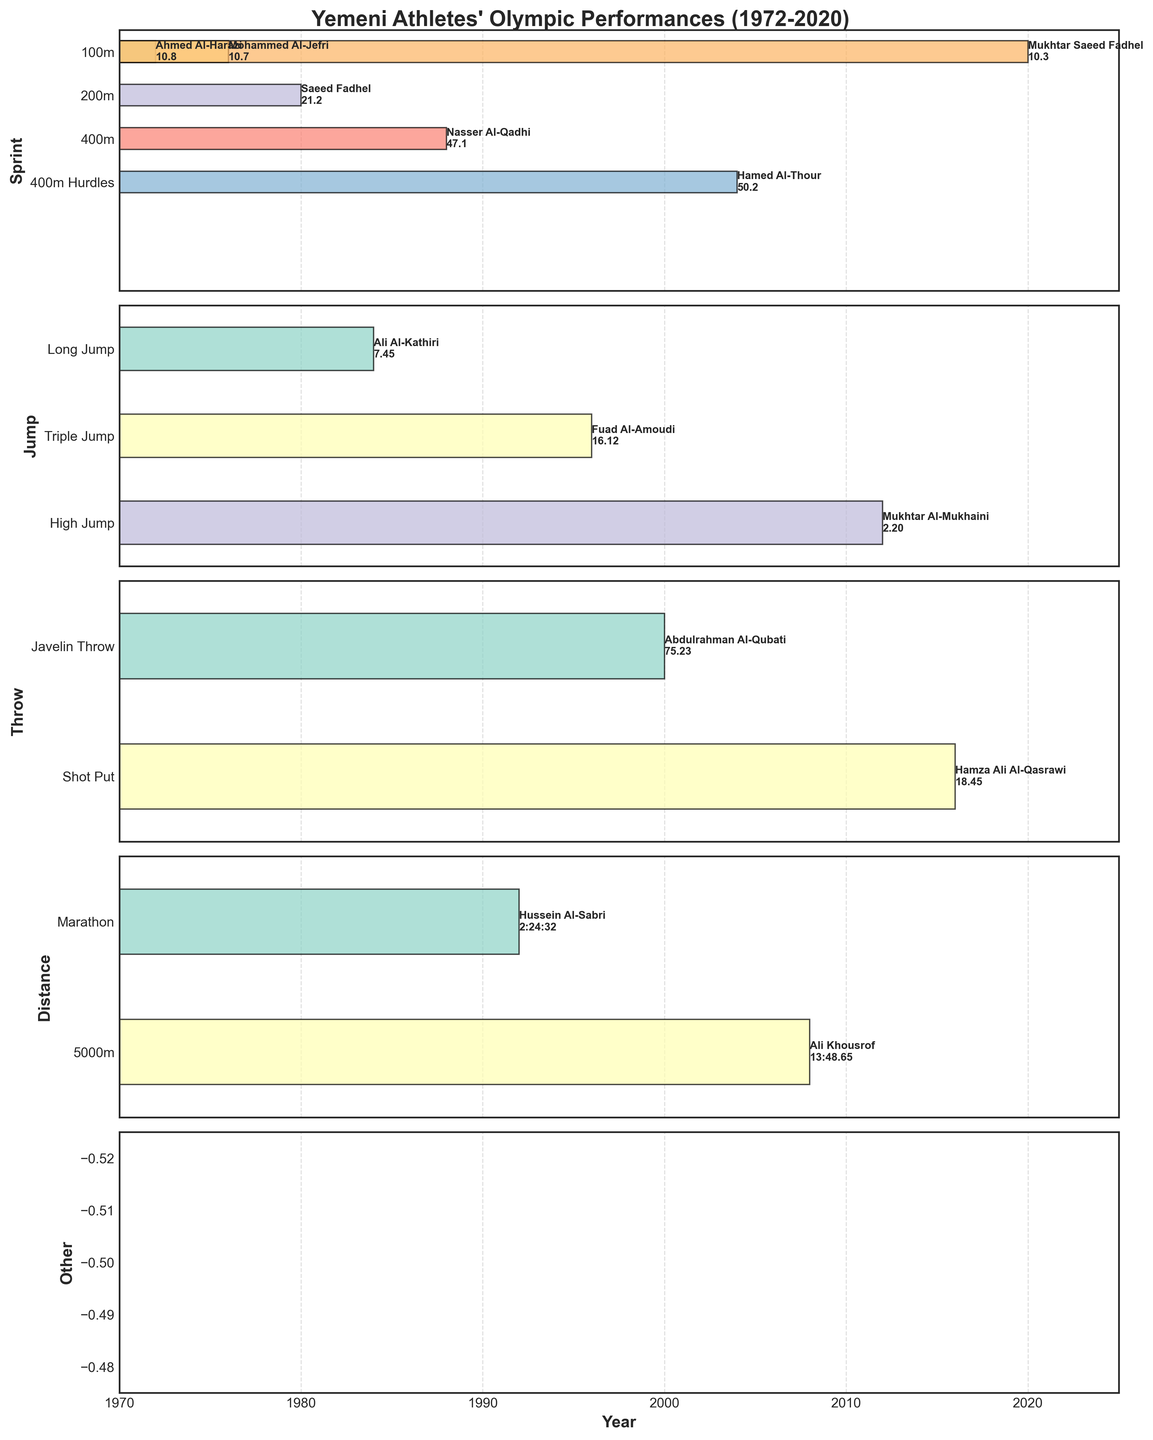In which year did Mukhtar Saeed Fadhel participate in the 100m event, and what was his performance? Mukhtar Saeed Fadhel's performance and year are highlighted in the Sprint category section of the plot, where you can see the year 2020 and the corresponding performance of 10.3.
Answer: 2020, 10.3 How many athletes represented Yemen in the "Jump" category, and what events did they participate in? There are three events under the Jump category: Long Jump, Triple Jump, and High Jump. By examining those events in the plot, we can see three athletes: Ali Al-Kathiri (Long Jump), Fuad Al-Amoudi (Triple Jump), and Mukhtar Al-Mukhaini (High Jump).
Answer: 3 athletes, Long Jump, Triple Jump, High Jump Which event had the highest number of different athletes participating across the years? View each subplot to count the number of athletes per event. The 100m event in the Sprint category has the most athletes, with Ahmed Al-Harazi, Mohammed Al-Jefri, and Mukhtar Saeed Fadhel totaling 3.
Answer: 100m, 3 athletes What's the range of years for Yemeni athletes' participation in Sprint events, and what are those events? The Sprint events include ‘100m’, ‘200m’, ‘400m’, and ‘400m Hurdles’. Referring to the plot, the earliest year is 1972 (Ahmed Al-Harazi in the 100m) and the latest is 2020 (Mukhtar Saeed Fadhel in the 100m). The events in this range are 100m, 200m, 400m, and 400m Hurdles.
Answer: 1972-2020, 100m, 200m, 400m, 400m Hurdles Who participated in the most recent Jump event and in which year? The most recent Jump event can be found in the Jump category section. It is the High Jump event in 2012 with Mukhtar Al-Mukhaini.
Answer: Mukhtar Al-Mukhaini, 2012 How many events fall under the "Throw" category, and what were their years of participation? The Throw category includes the Javelin Throw and Shot Put as shown in their respective subplot. By observing the plot, Javelin Throw was in 2000 and Shot Put in 2016.
Answer: 2 events, 2000, 2016 Which athlete had the best performance in the '100m' event and what was the time? The 100m event can be found in the Sprint category. Comparing the performances, Mukhtar Saeed Fadhel in 2020 has the best time of 10.3.
Answer: Mukhtar Saeed Fadhel, 10.3 What is the average performance time for Yemeni athletes in the 400m events? The plot in the Sprint category shows 400m and 400m Hurdles with athletes’ times: Nasser Al-Qadhi (47.1) and Hamed Al-Thour (50.2). The average is calculated as (47.1 + 50.2) / 2.
Answer: 48.65 Which category has the fewest data points (athlete participations)? Assess each subplot to count the data points. The "Other" category has the fewest data points as there are no additional events outside the categorized ones.
Answer: Other What are the performance times of Yemeni athletes in distance events, and who were they? The Distance category includes Marathon and 5000m. The plot shows Hussein Al-Sabri (2:24:32 in Marathon) and Ali Khousrof (13:48.65 in 5000m).
Answer: 2:24:32 (Hussein Al-Sabri), 13:48.65 (Ali Khousrof) 